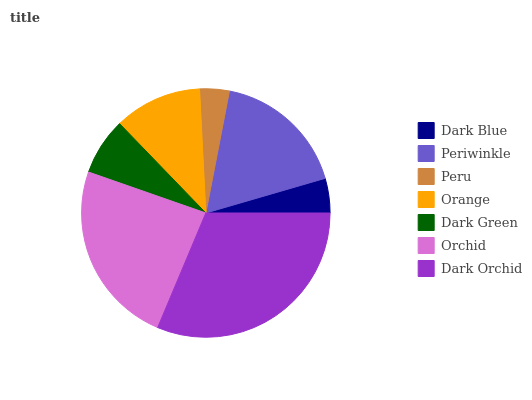Is Peru the minimum?
Answer yes or no. Yes. Is Dark Orchid the maximum?
Answer yes or no. Yes. Is Periwinkle the minimum?
Answer yes or no. No. Is Periwinkle the maximum?
Answer yes or no. No. Is Periwinkle greater than Dark Blue?
Answer yes or no. Yes. Is Dark Blue less than Periwinkle?
Answer yes or no. Yes. Is Dark Blue greater than Periwinkle?
Answer yes or no. No. Is Periwinkle less than Dark Blue?
Answer yes or no. No. Is Orange the high median?
Answer yes or no. Yes. Is Orange the low median?
Answer yes or no. Yes. Is Dark Blue the high median?
Answer yes or no. No. Is Orchid the low median?
Answer yes or no. No. 